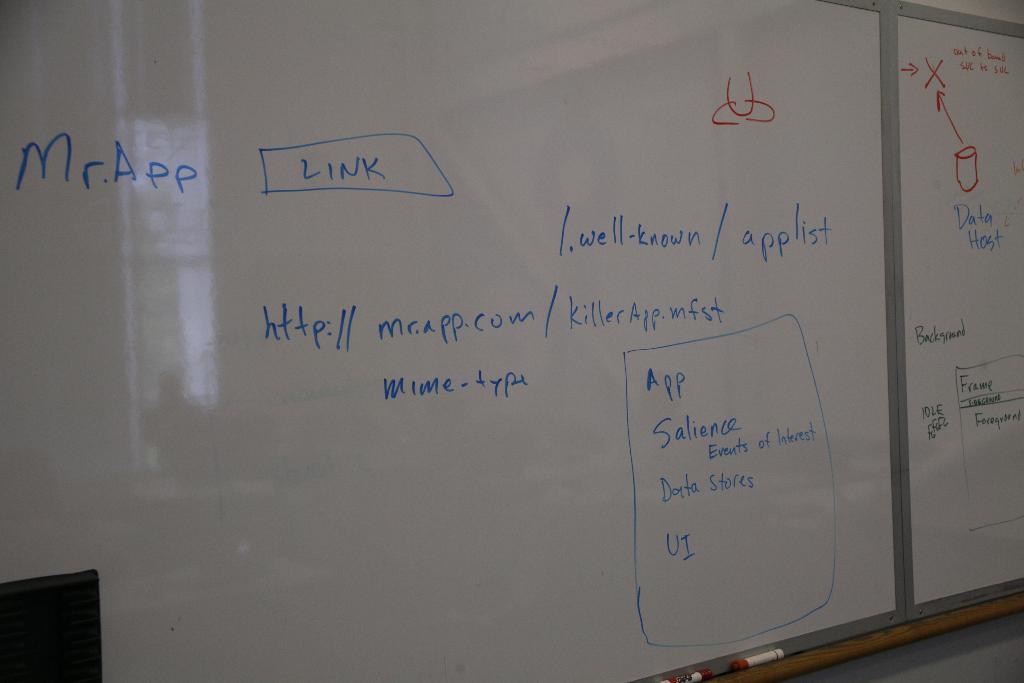What is the teacher trying to lecture about?
Your answer should be compact. Mr.app. 